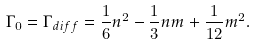Convert formula to latex. <formula><loc_0><loc_0><loc_500><loc_500>\Gamma _ { 0 } = \Gamma _ { d i f f } = \frac { 1 } { 6 } n ^ { 2 } - \frac { 1 } { 3 } n m + \frac { 1 } { 1 2 } m ^ { 2 } .</formula> 